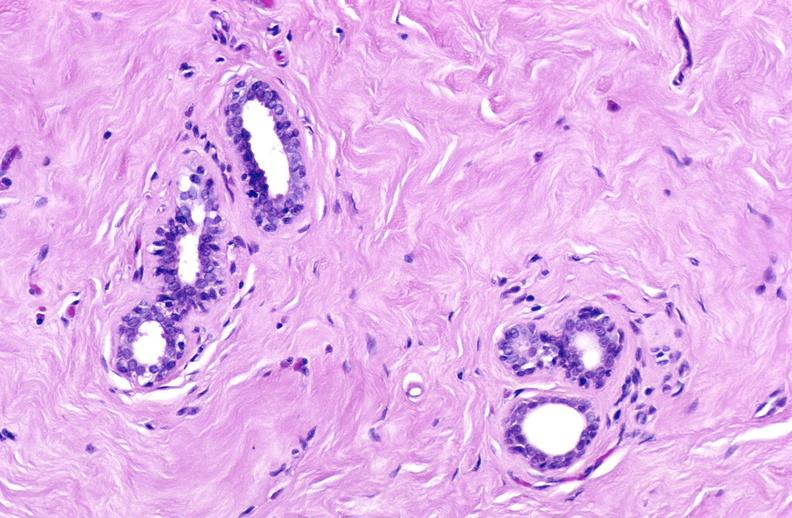does this image show breast, fibroadenoma?
Answer the question using a single word or phrase. Yes 